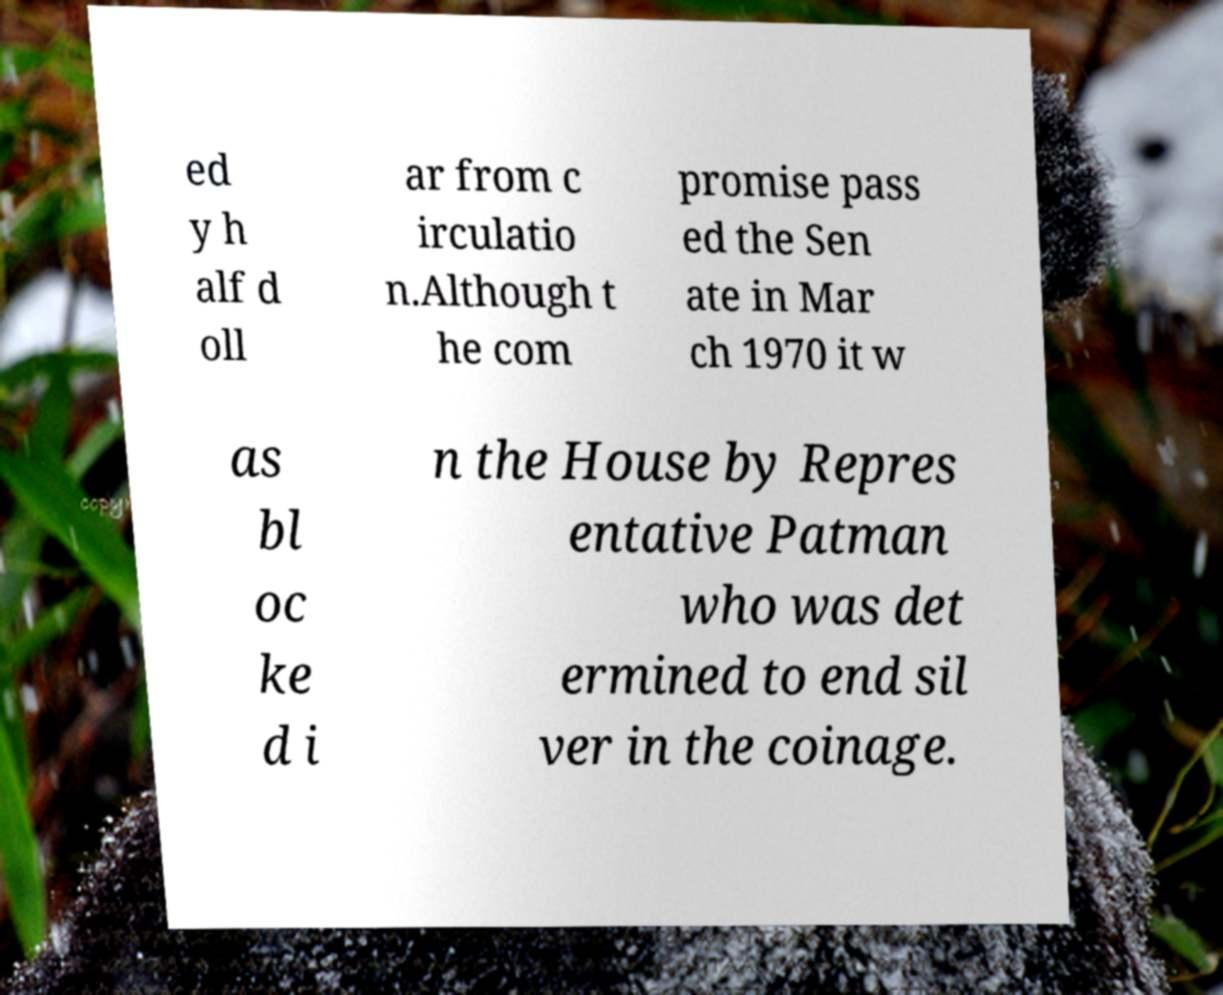Please read and relay the text visible in this image. What does it say? ed y h alf d oll ar from c irculatio n.Although t he com promise pass ed the Sen ate in Mar ch 1970 it w as bl oc ke d i n the House by Repres entative Patman who was det ermined to end sil ver in the coinage. 